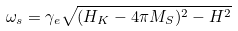Convert formula to latex. <formula><loc_0><loc_0><loc_500><loc_500>\omega _ { s } = \gamma _ { e } \sqrt { ( H _ { K } - 4 \pi M _ { S } ) ^ { 2 } - H ^ { 2 } }</formula> 